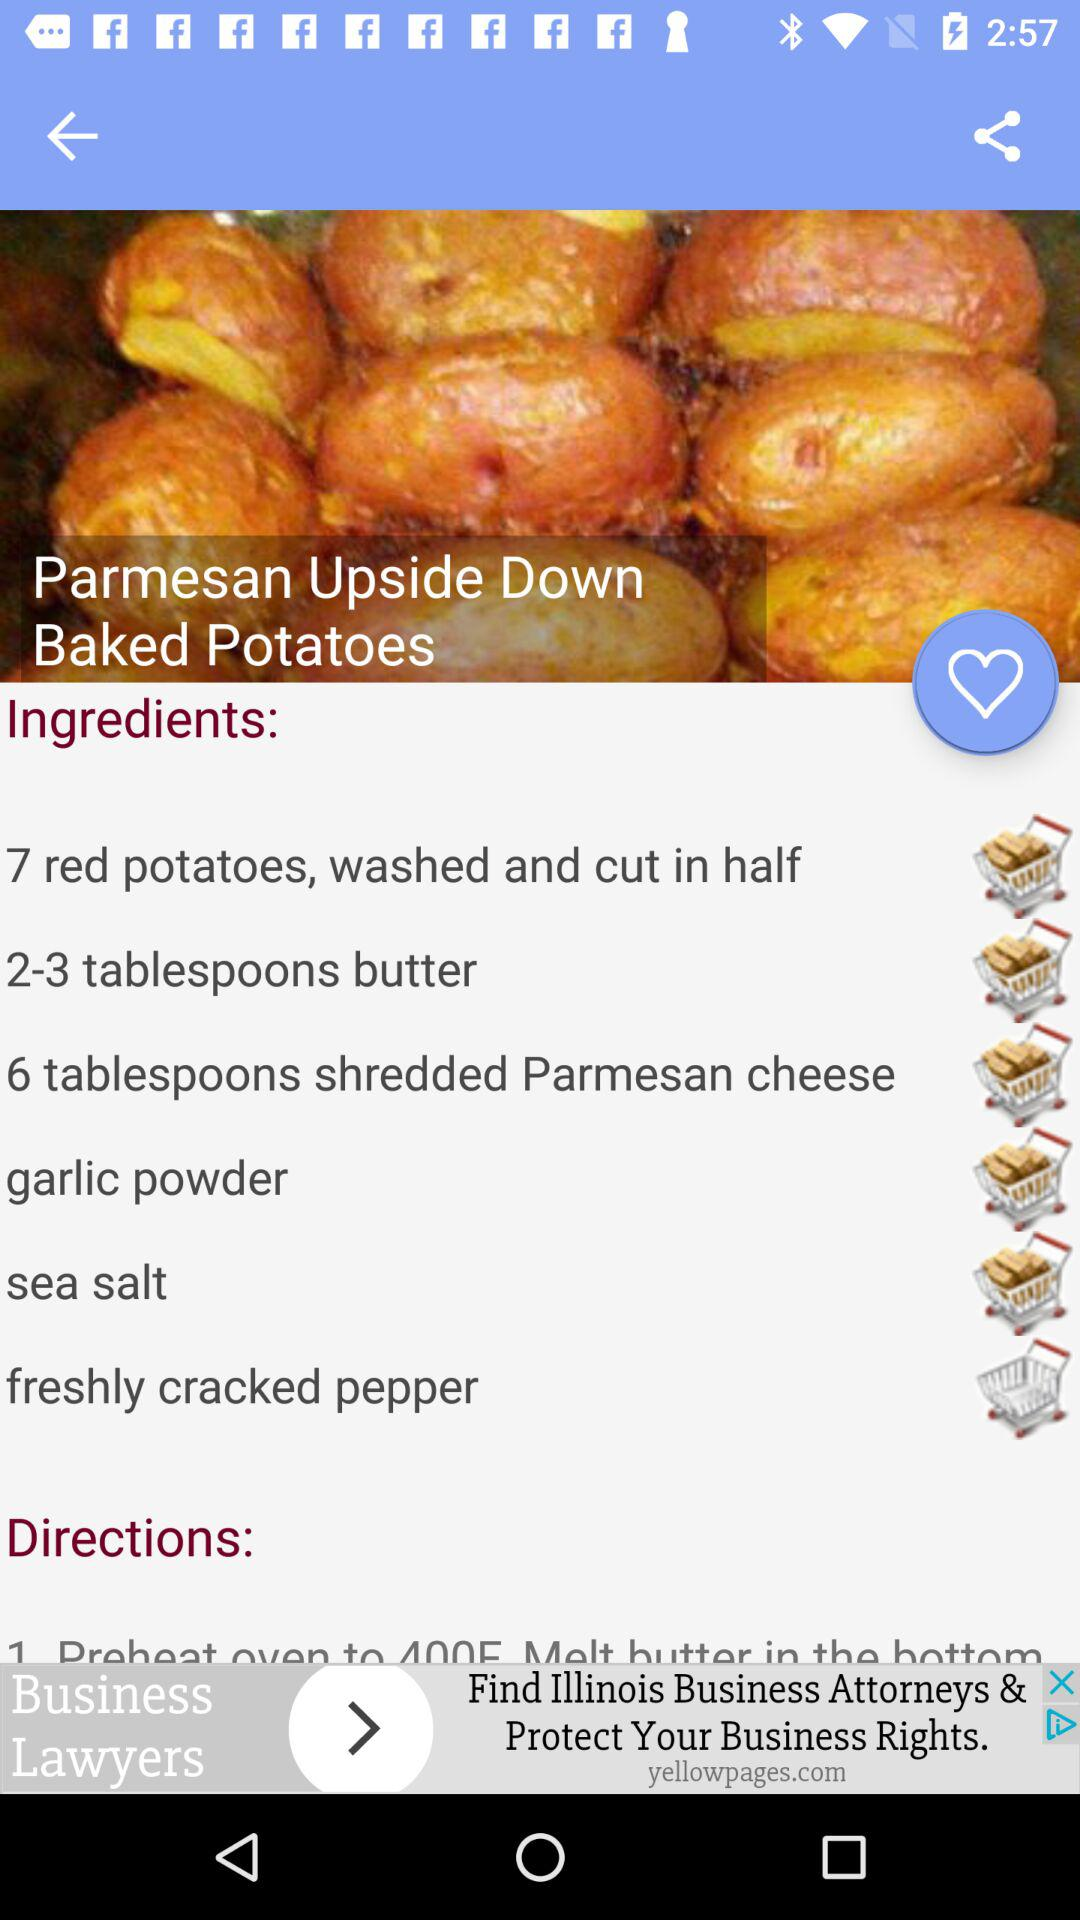What's the recipe name? The recipe name is "Parmesan Upside Down Baked Potatoes". 